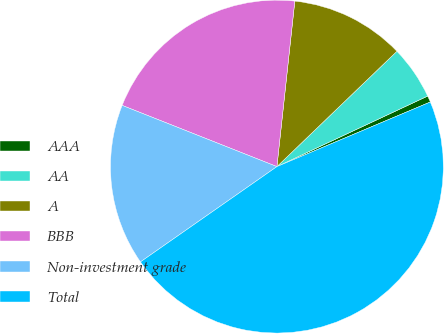<chart> <loc_0><loc_0><loc_500><loc_500><pie_chart><fcel>AAA<fcel>AA<fcel>A<fcel>BBB<fcel>Non-investment grade<fcel>Total<nl><fcel>0.62%<fcel>5.22%<fcel>11.1%<fcel>20.72%<fcel>15.7%<fcel>46.64%<nl></chart> 